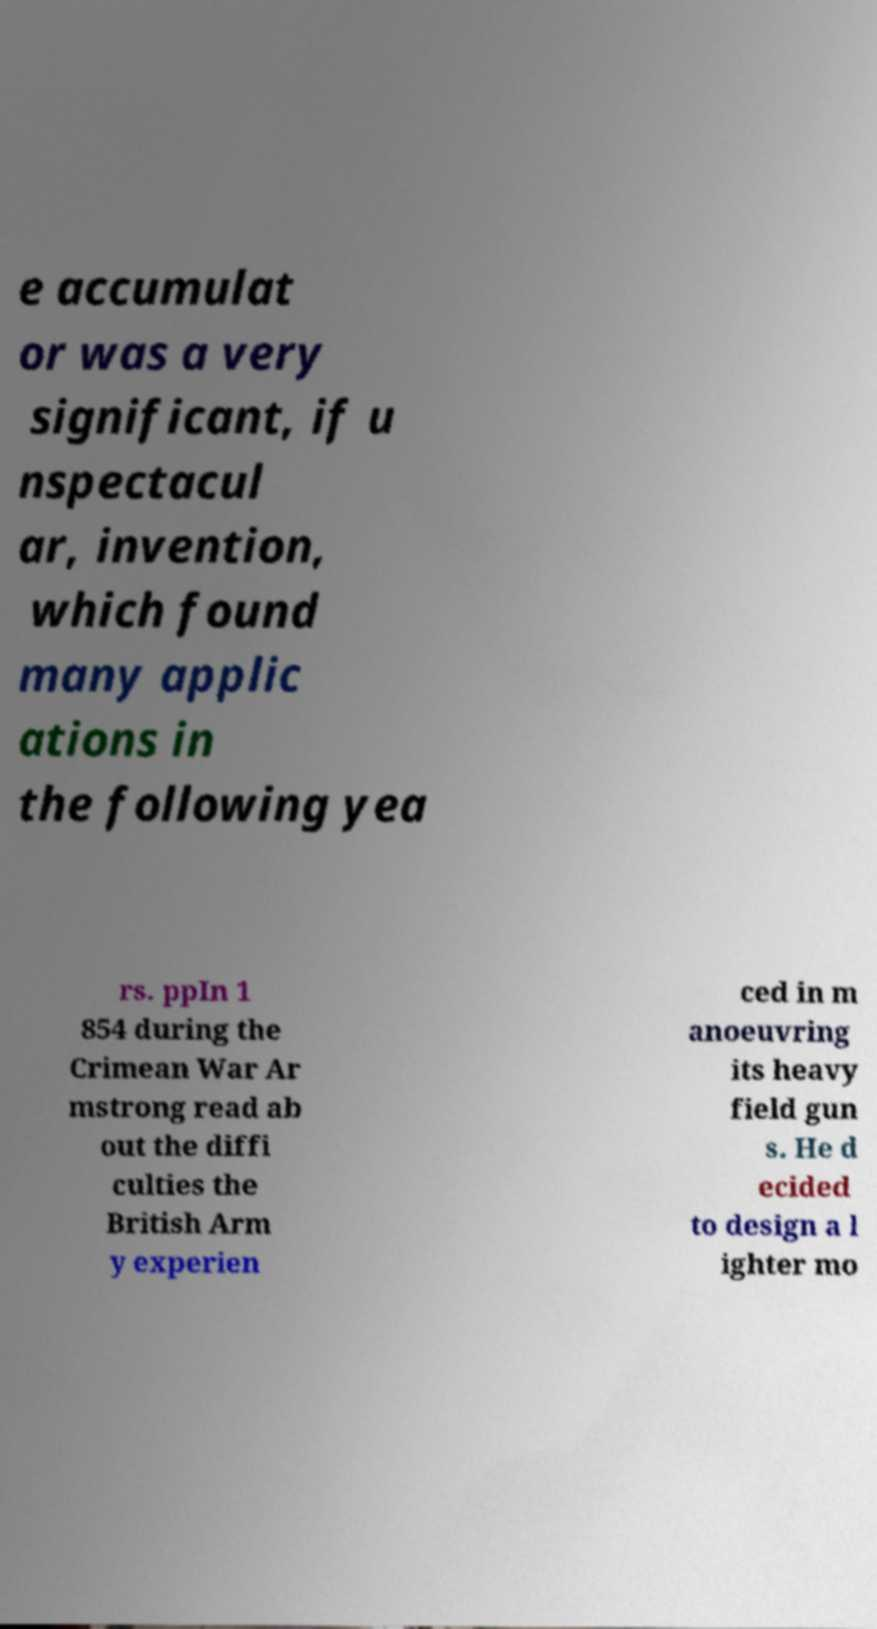Please read and relay the text visible in this image. What does it say? e accumulat or was a very significant, if u nspectacul ar, invention, which found many applic ations in the following yea rs. ppIn 1 854 during the Crimean War Ar mstrong read ab out the diffi culties the British Arm y experien ced in m anoeuvring its heavy field gun s. He d ecided to design a l ighter mo 